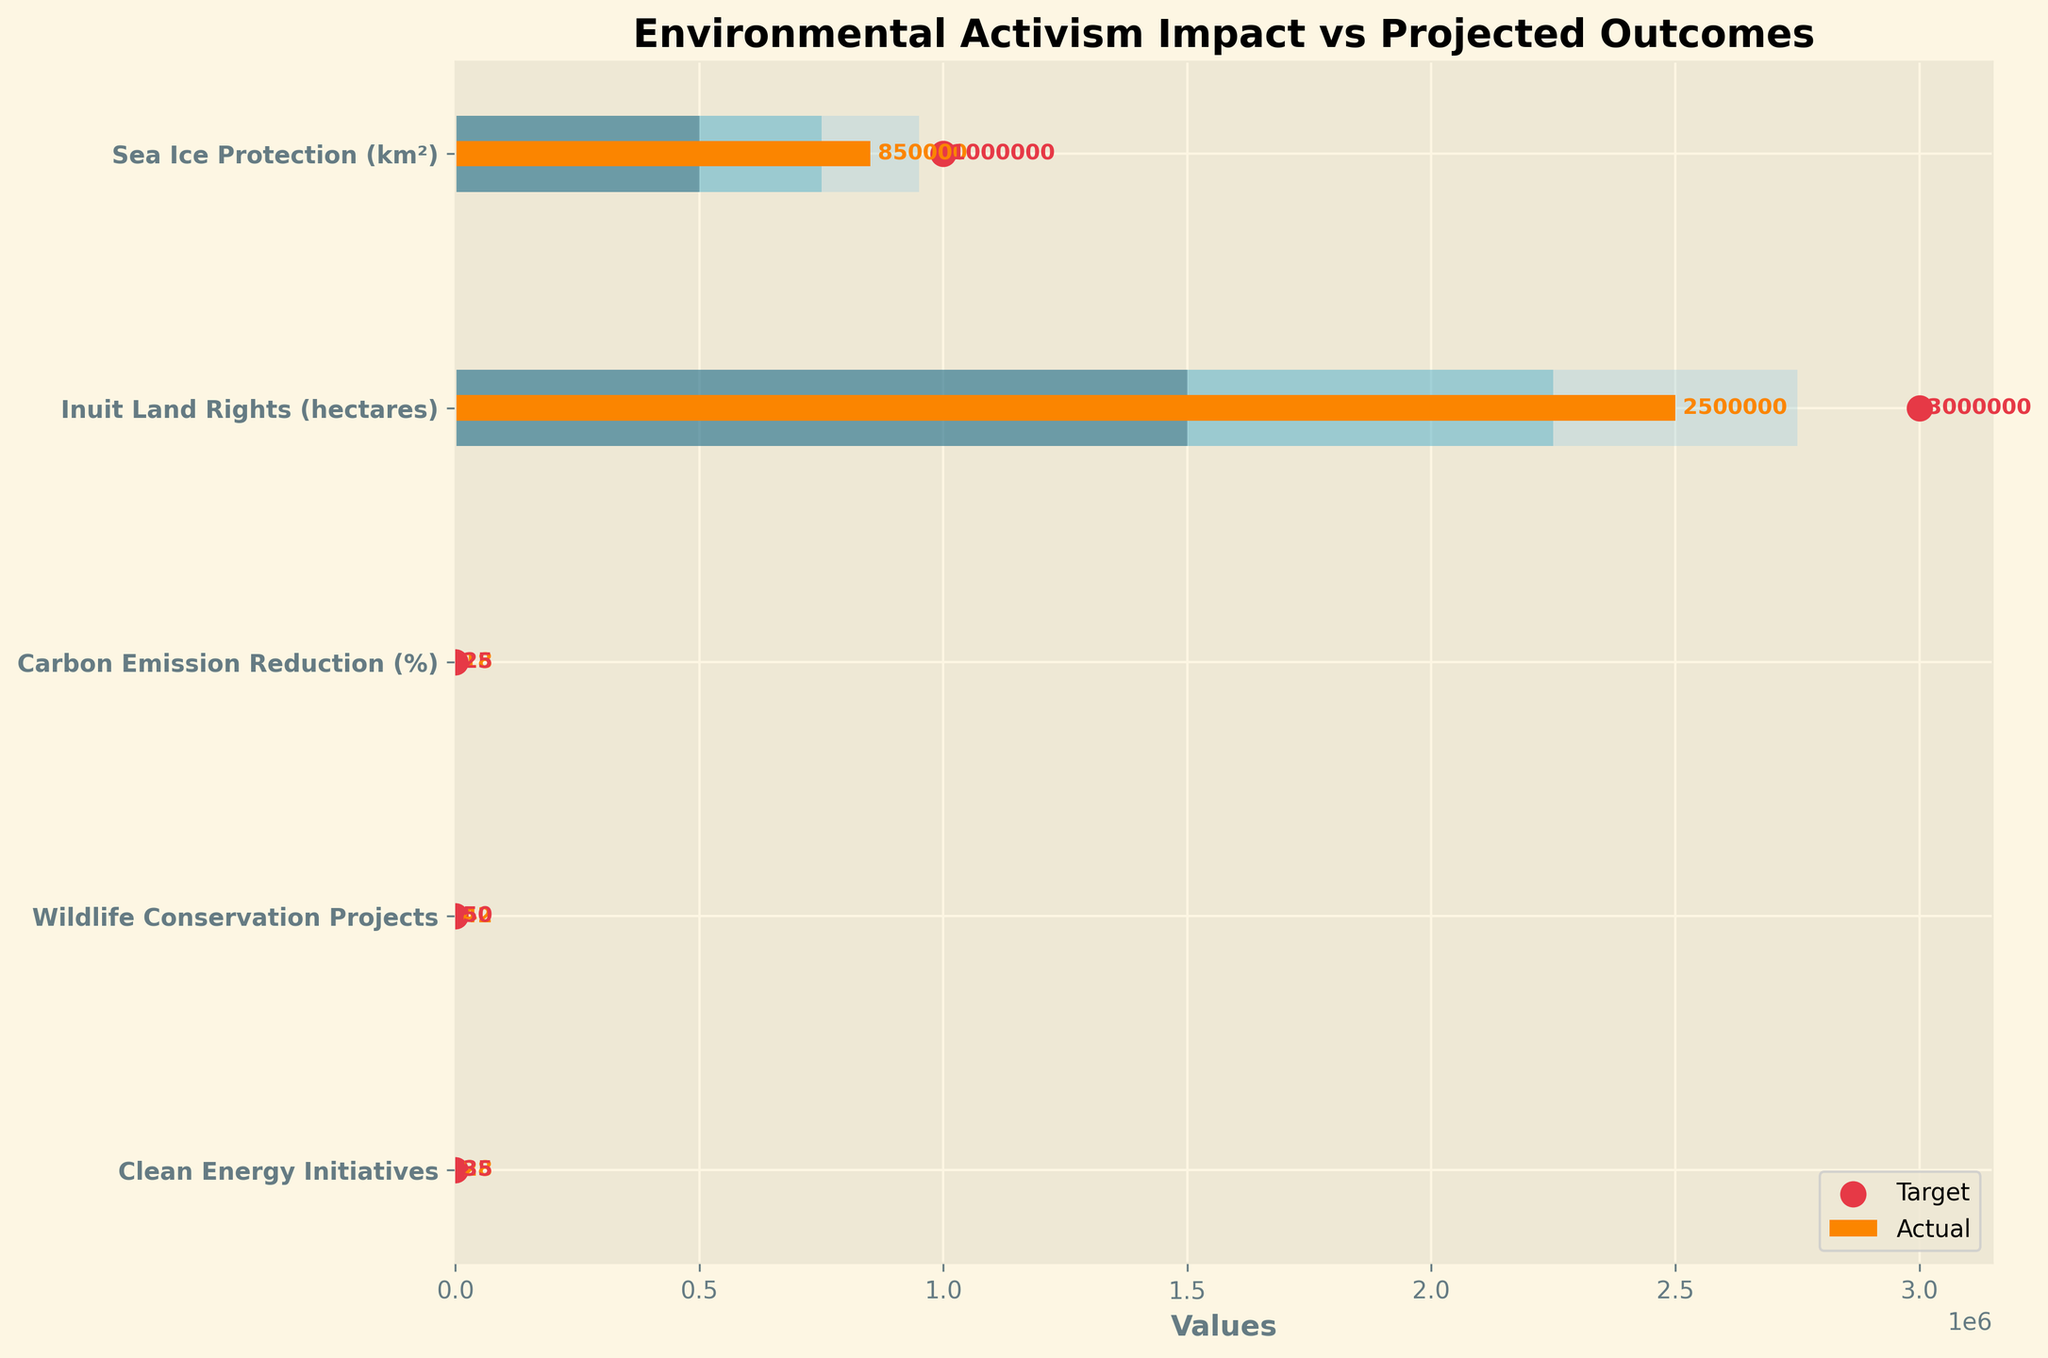What is the title of the figure? The title is shown at the top of the figure and usually conveys the main topic or insight the figure intends to present.
Answer: Environmental Activism Impact vs Projected Outcomes Which category has the highest "Actual" value? The highest "Actual" value is visually the longest bar among the categories. By looking at the bars, "Inuit Land Rights (hectares)" is the longest.
Answer: Inuit Land Rights (hectares) How many categories have "Actual" values greater than or equal to their "Satisfactory" thresholds? To answer this, compare the "Actual" bar lengths with the "Satisfactory" bar lengths for each category. Only the categories "Sea Ice Protection (km²)," "Inuit Land Rights (hectares)," and "Wildlife Conservation Projects" meet this criterion.
Answer: 3 What is the difference between the "Target" and "Actual" values for "Carbon Emission Reduction (%)"? Look at the bullet chart for "Carbon Emission Reduction (%)". The "Target" value (indicated by a dot) is 25, and the "Actual" value (bar) is 18. Subtract 18 from 25 (25 - 18).
Answer: 7 Which category is closest to its "Target" value? By checking the distances between the ends of the "Actual" bars and their corresponding target dots, "Carbon Emission Reduction (%)" seems to have the smallest distance.
Answer: Carbon Emission Reduction (%) How many categories have "Actual" values below their "Poor" thresholds? Compare the "Actual" bar lengths with the "Poor" thresholds for each category. None of the "Actual" values are below their "Poor" thresholds.
Answer: 0 Which category has the smallest gap between "Actual" and "Good" values? For each category, subtract the "Actual" value from the "Good" threshold and identify the smallest result. The smallest gap is for "Wildlife Conservation Projects," where the "Good" value is 45, and the "Actual" value is 42.
Answer: Wildlife Conservation Projects What is the average "Actual" value across all categories? Sum up all "Actual" values (850000 + 2500000 + 18 + 42 + 28) and divide by 5.
Answer: 670017.6 